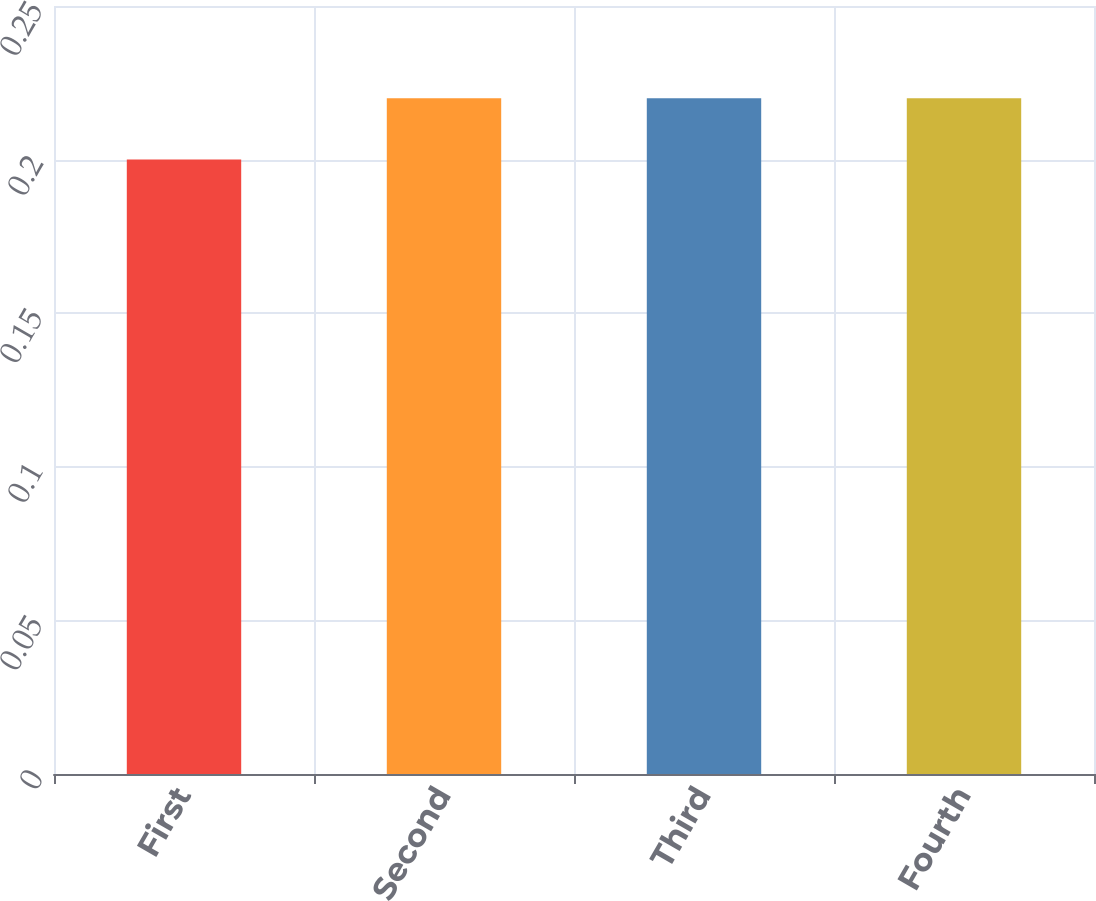Convert chart to OTSL. <chart><loc_0><loc_0><loc_500><loc_500><bar_chart><fcel>First<fcel>Second<fcel>Third<fcel>Fourth<nl><fcel>0.2<fcel>0.22<fcel>0.22<fcel>0.22<nl></chart> 